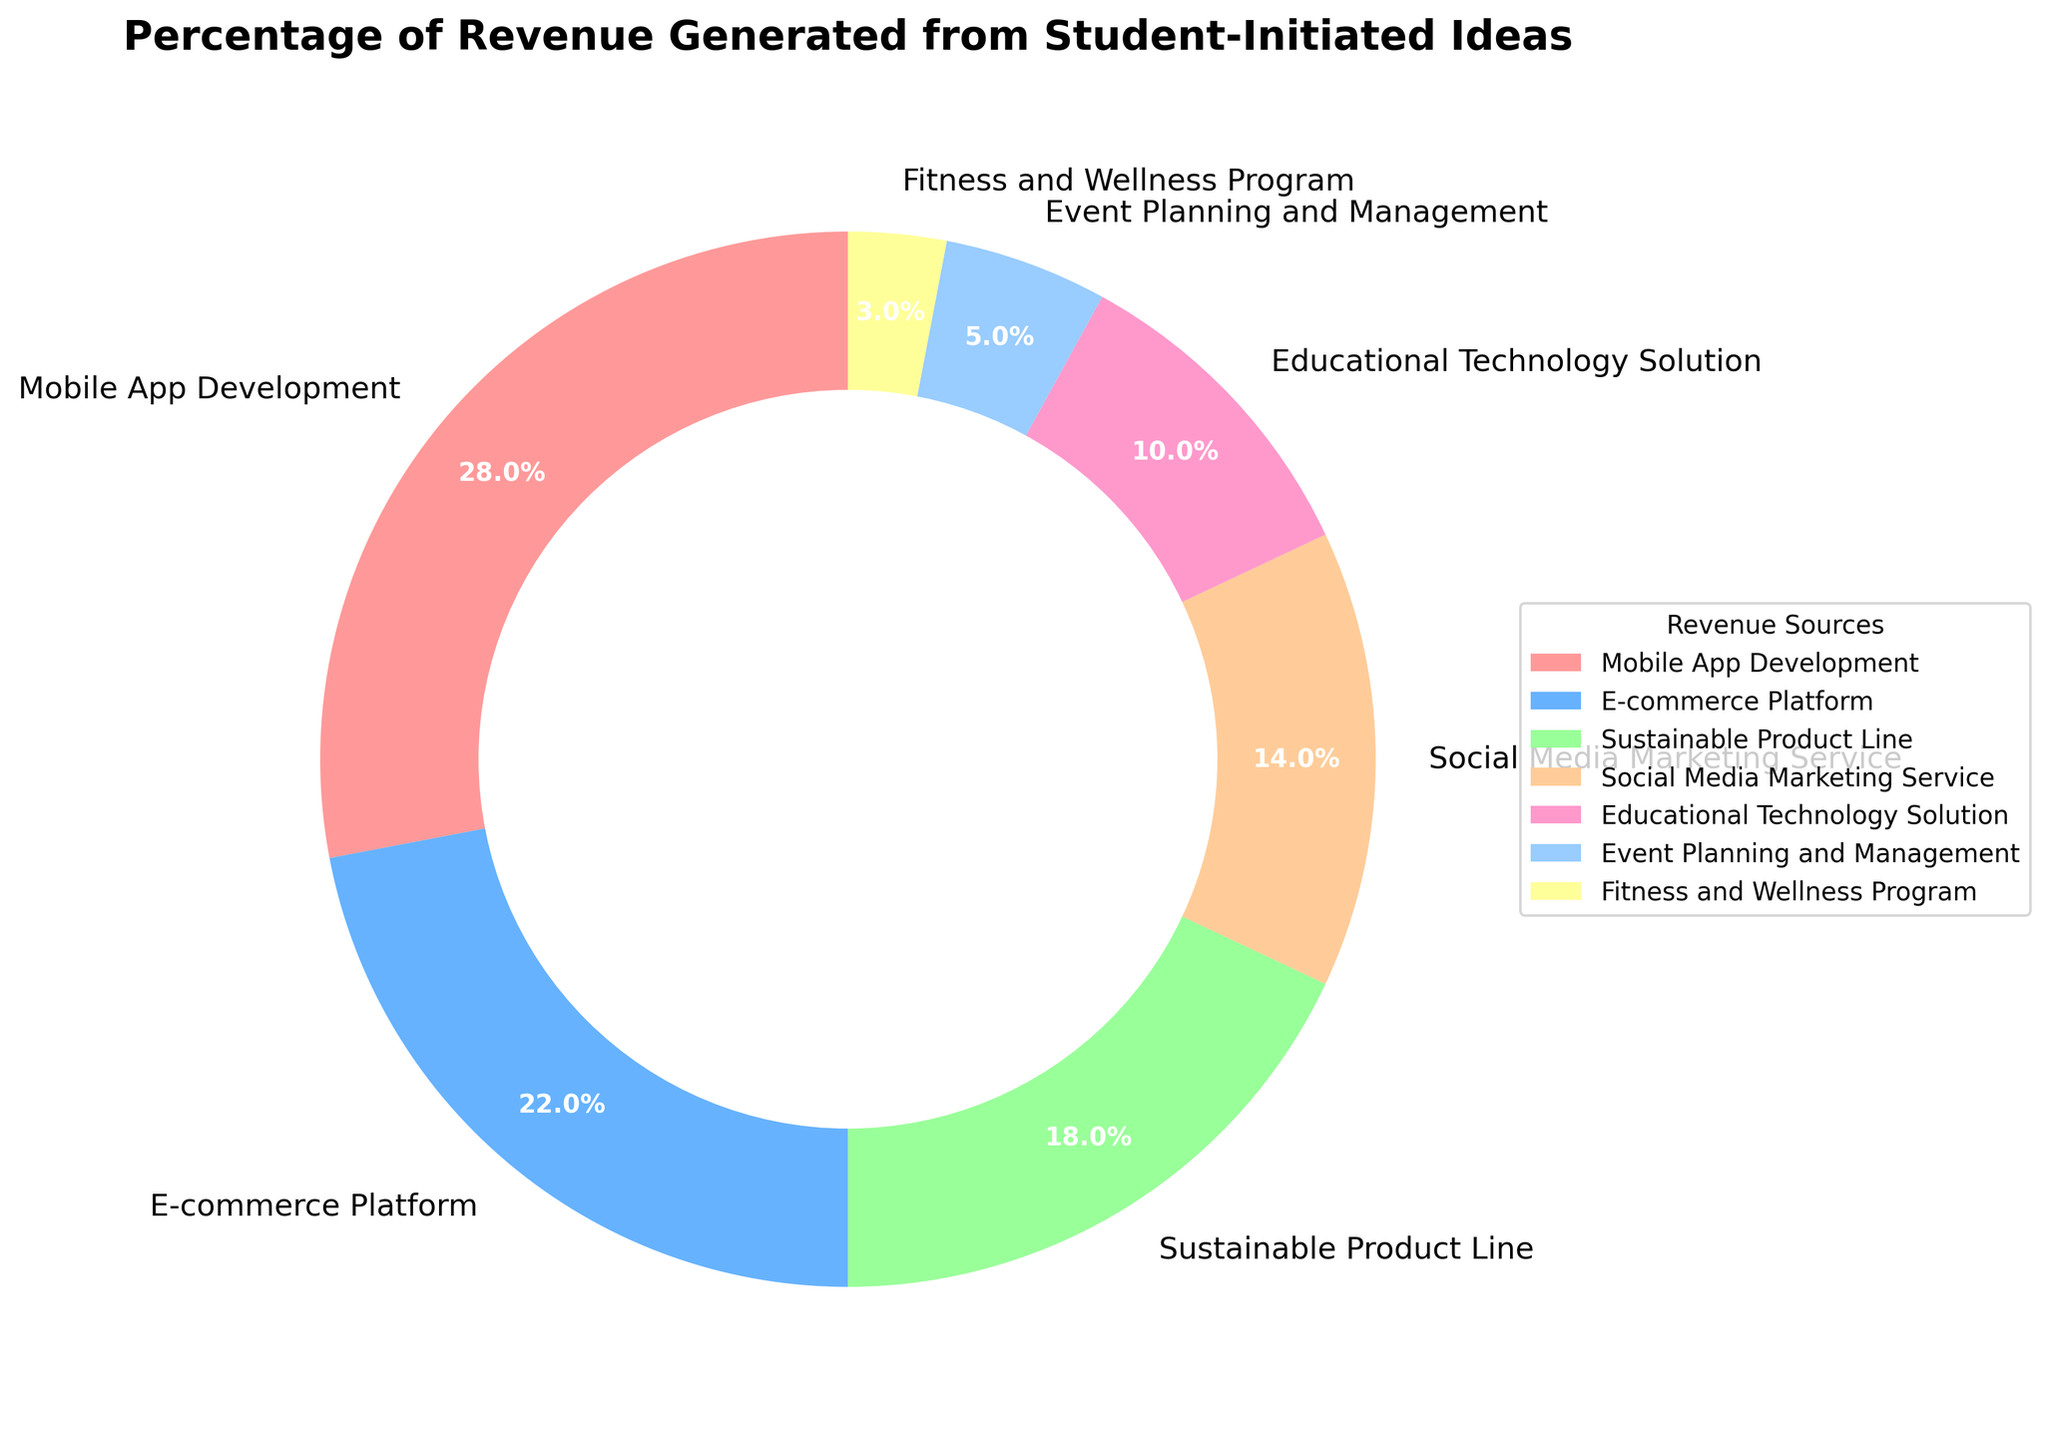What percentage of the revenue is generated by the top three student-initiated ideas? The top three sources are Mobile App Development (28%), E-commerce Platform (22%), and Sustainable Product Line (18%). Adding these up gives us 28 + 22 + 18 = 68%.
Answer: 68% Which student-initiated idea contributes the least to the revenue? The Fitness and Wellness Program has the smallest percentage of revenue at 3%, as indicated by the figure.
Answer: Fitness and Wellness Program What is the combined percentage of revenue generated by Event Planning and Management and Fitness and Wellness Program? Event Planning and Management contributes 5%, and Fitness and Wellness Program contributes 3%. Adding these, we get 5 + 3 = 8%.
Answer: 8% How does the revenue percentage of Mobile App Development compare to Educational Technology Solution? Mobile App Development generates 28% while Educational Technology Solution generates 10%. Hence, Mobile App Development generates 28 - 10 = 18% more.
Answer: 18% more Which revenue source is represented by the green-colored wedge in the pie chart? By observing the color scheme, the green color corresponds to the Sustainable Product Line, which generates 18% of the revenue.
Answer: Sustainable Product Line What is the average percentage of revenue generated by the bottom three sources? The bottom three sources are Event Planning and Management (5%), Fitness and Wellness Program (3%), and Educational Technology Solution (10%). Summing these gives 5 + 3 + 10 = 18%. Dividing by three sources, we get 18 / 3 = 6%.
Answer: 6% How much more revenue does Social Media Marketing Service generate compared to Event Planning and Management? Social Media Marketing Service generates 14%, and Event Planning and Management generates 5%. So, the difference is 14 - 5 = 9%.
Answer: 9% Is the revenue percentage from E-commerce Platform greater or less than the combined revenue of Event Planning and Management and Educational Technology Solution? E-commerce Platform generates 22%. The combined revenue of Event Planning and Management (5%) and Educational Technology Solution (10%) is 5 + 10 = 15%. Therefore, 22% is greater than 15%.
Answer: Greater Which two revenue sources together add up to a quarter of the total revenue? Social Media Marketing Service (14%) and Educational Technology Solution (10%) together contribute 14 + 10 = 24%, which is approximately a quarter of 100%.
Answer: Social Media Marketing Service and Educational Technology Solution 